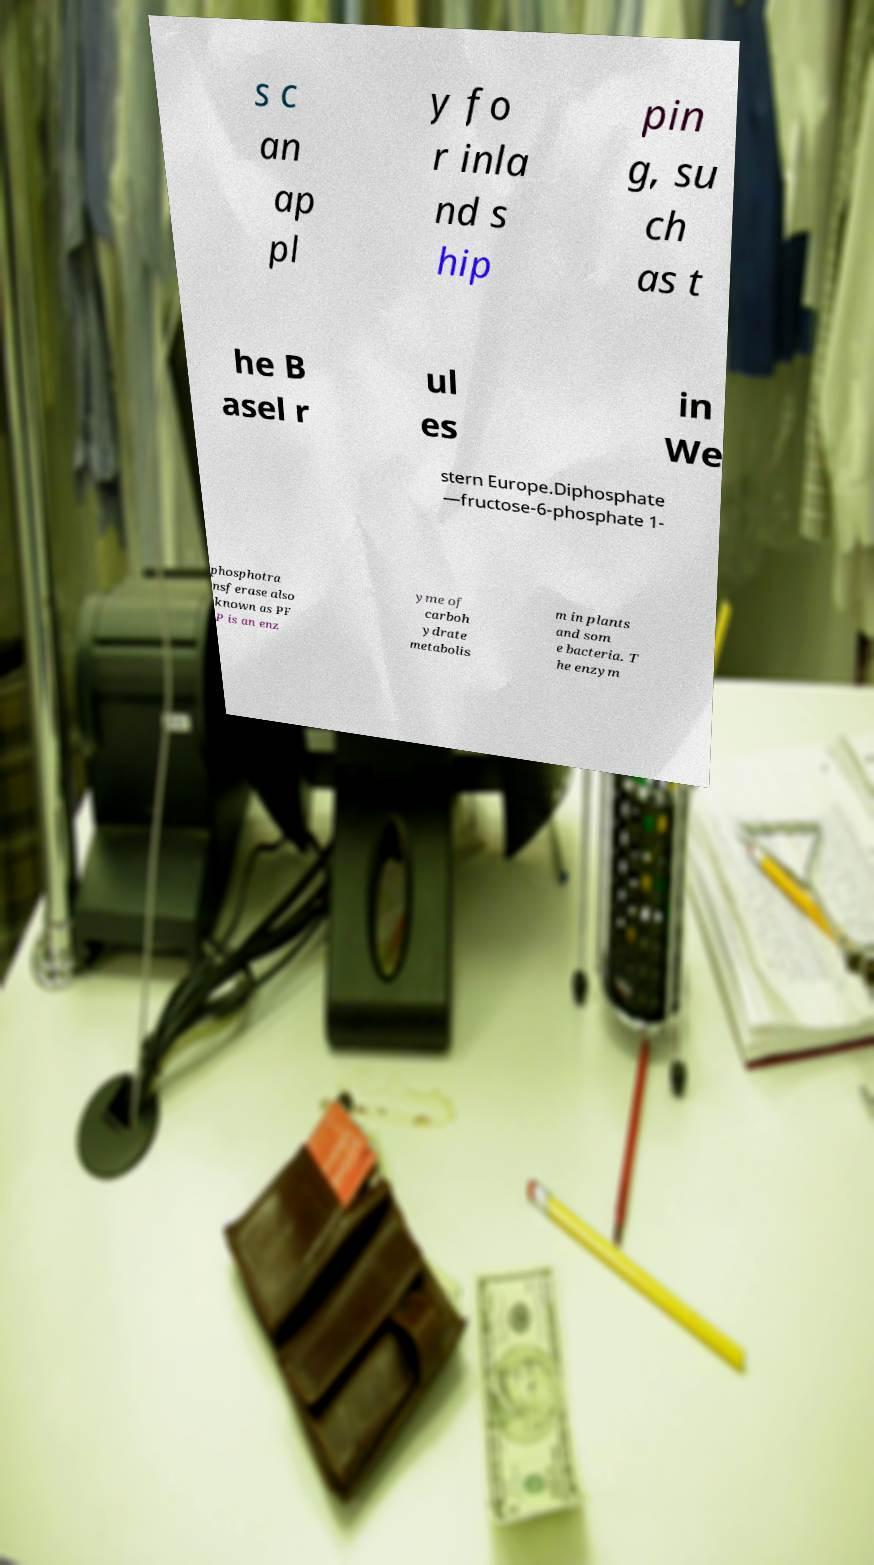Could you extract and type out the text from this image? s c an ap pl y fo r inla nd s hip pin g, su ch as t he B asel r ul es in We stern Europe.Diphosphate —fructose-6-phosphate 1- phosphotra nsferase also known as PF P is an enz yme of carboh ydrate metabolis m in plants and som e bacteria. T he enzym 